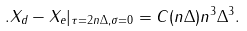Convert formula to latex. <formula><loc_0><loc_0><loc_500><loc_500>. X _ { d } - X _ { e } | _ { \tau = 2 n \Delta , \sigma = 0 } = C ( n \Delta ) n ^ { 3 } \Delta ^ { 3 } .</formula> 